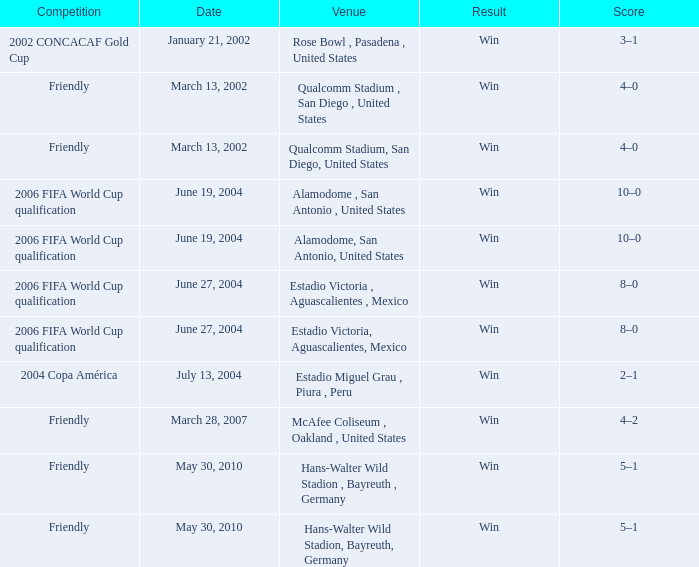What competition has June 19, 2004 as the date? 2006 FIFA World Cup qualification, 2006 FIFA World Cup qualification. 